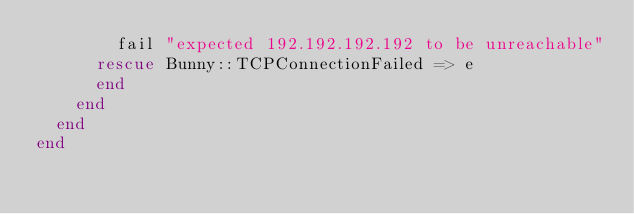<code> <loc_0><loc_0><loc_500><loc_500><_Ruby_>        fail "expected 192.192.192.192 to be unreachable"
      rescue Bunny::TCPConnectionFailed => e
      end
    end
  end
end
</code> 